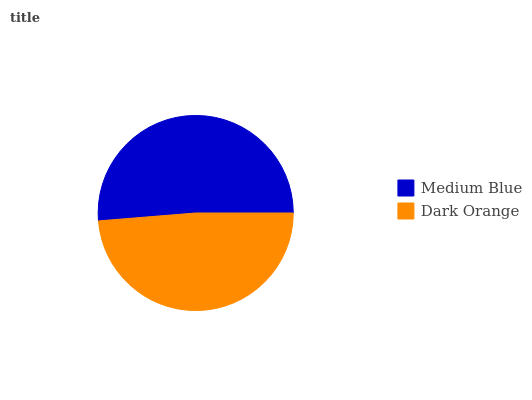Is Dark Orange the minimum?
Answer yes or no. Yes. Is Medium Blue the maximum?
Answer yes or no. Yes. Is Dark Orange the maximum?
Answer yes or no. No. Is Medium Blue greater than Dark Orange?
Answer yes or no. Yes. Is Dark Orange less than Medium Blue?
Answer yes or no. Yes. Is Dark Orange greater than Medium Blue?
Answer yes or no. No. Is Medium Blue less than Dark Orange?
Answer yes or no. No. Is Medium Blue the high median?
Answer yes or no. Yes. Is Dark Orange the low median?
Answer yes or no. Yes. Is Dark Orange the high median?
Answer yes or no. No. Is Medium Blue the low median?
Answer yes or no. No. 